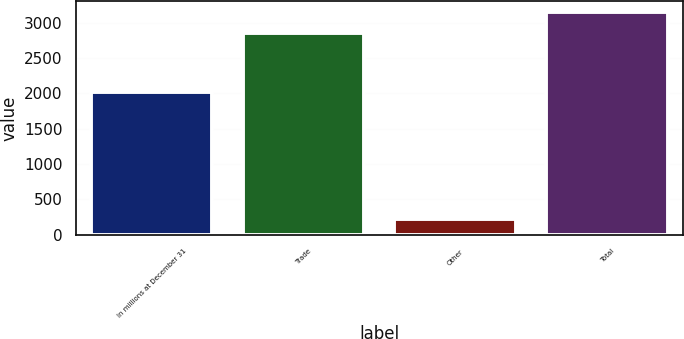Convert chart to OTSL. <chart><loc_0><loc_0><loc_500><loc_500><bar_chart><fcel>In millions at December 31<fcel>Trade<fcel>Other<fcel>Total<nl><fcel>2014<fcel>2860<fcel>223<fcel>3146<nl></chart> 